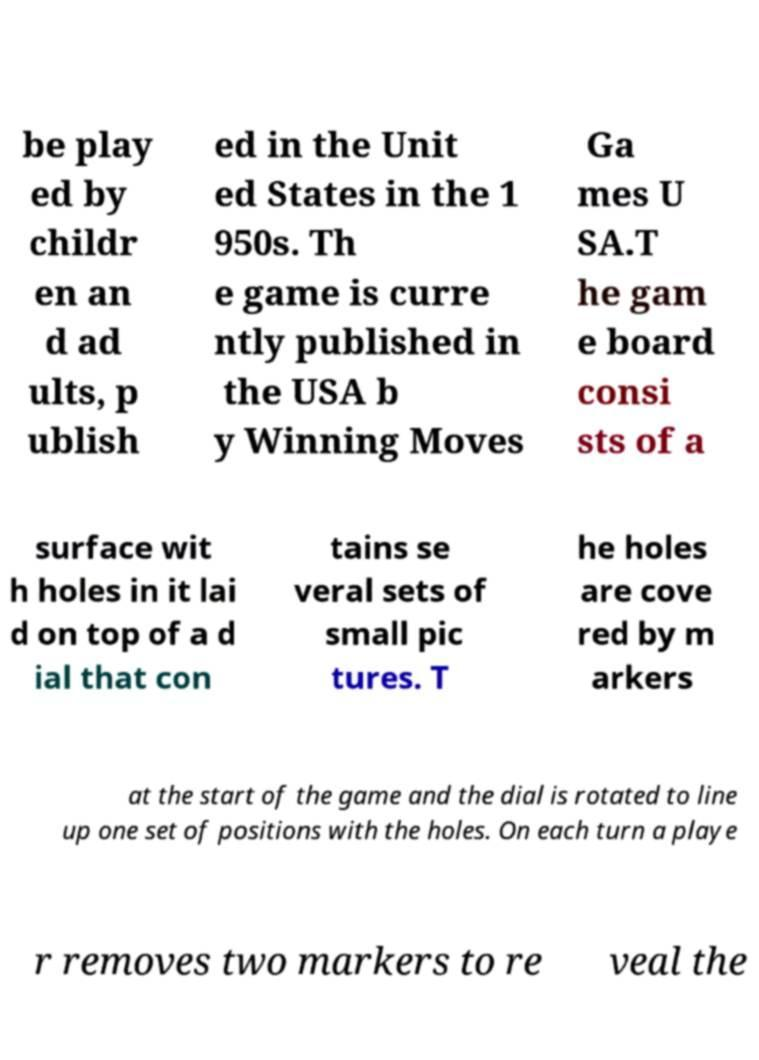Can you read and provide the text displayed in the image?This photo seems to have some interesting text. Can you extract and type it out for me? be play ed by childr en an d ad ults, p ublish ed in the Unit ed States in the 1 950s. Th e game is curre ntly published in the USA b y Winning Moves Ga mes U SA.T he gam e board consi sts of a surface wit h holes in it lai d on top of a d ial that con tains se veral sets of small pic tures. T he holes are cove red by m arkers at the start of the game and the dial is rotated to line up one set of positions with the holes. On each turn a playe r removes two markers to re veal the 